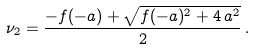Convert formula to latex. <formula><loc_0><loc_0><loc_500><loc_500>\nu _ { 2 } = \frac { - f ( - a ) + \sqrt { f ( - a ) ^ { 2 } + 4 \, a ^ { 2 } } } { 2 } \, .</formula> 